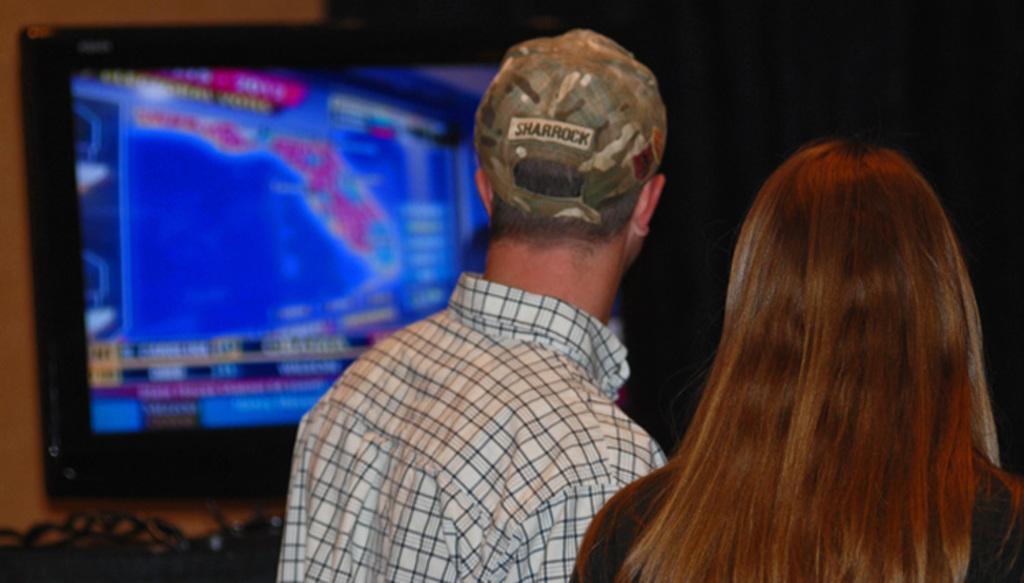Please provide a concise description of this image. There is a man wearing cap and standing near a woman. In the background, there is a screen near the wall and the background is dark in color. 